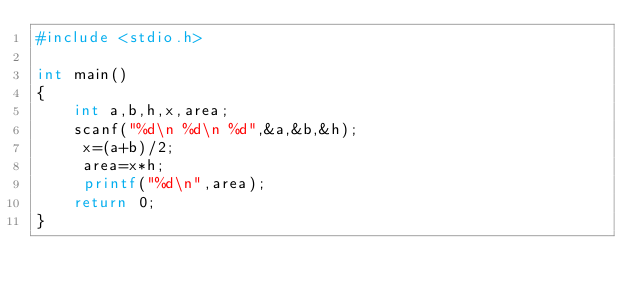Convert code to text. <code><loc_0><loc_0><loc_500><loc_500><_Awk_>#include <stdio.h>

int main()
{
    int a,b,h,x,area;
    scanf("%d\n %d\n %d",&a,&b,&h);
     x=(a+b)/2;
     area=x*h;
     printf("%d\n",area);
    return 0;
}
</code> 